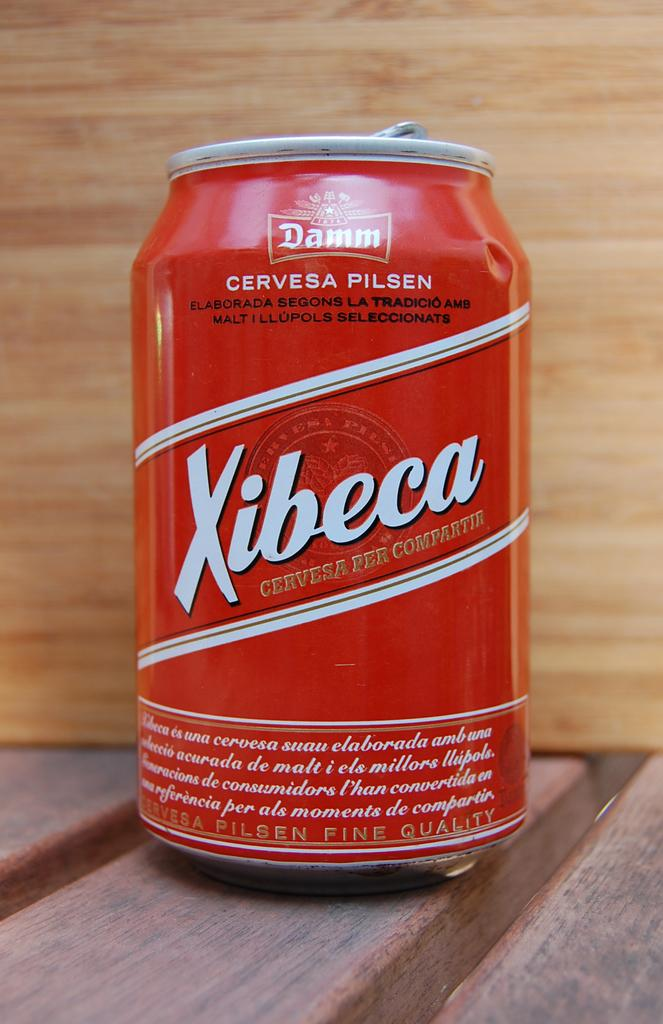What object is present in the image? There is a tin in the image. What color is the tin? The tin is red in color. What word is written on the tin? The word "xibeca" is written on the tin. How many eyes can be seen on the tin in the image? There are no eyes present on the tin in the image. 